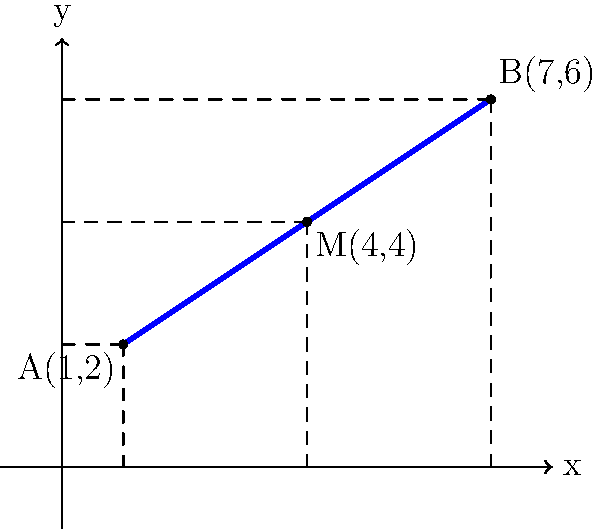In the early days of prosthetic limb design, determining the midpoint of a limb segment was crucial for balance and functionality. Given a prosthetic limb segment with endpoints A(1,2) and B(7,6), what are the coordinates of the midpoint M? To find the midpoint of a line segment, we use the midpoint formula:

$$ M_x = \frac{x_1 + x_2}{2}, \quad M_y = \frac{y_1 + y_2}{2} $$

Where $(x_1, y_1)$ are the coordinates of point A, and $(x_2, y_2)$ are the coordinates of point B.

Step 1: Calculate the x-coordinate of the midpoint:
$$ M_x = \frac{x_1 + x_2}{2} = \frac{1 + 7}{2} = \frac{8}{2} = 4 $$

Step 2: Calculate the y-coordinate of the midpoint:
$$ M_y = \frac{y_1 + y_2}{2} = \frac{2 + 6}{2} = \frac{8}{2} = 4 $$

Therefore, the coordinates of the midpoint M are (4, 4).
Answer: (4, 4) 